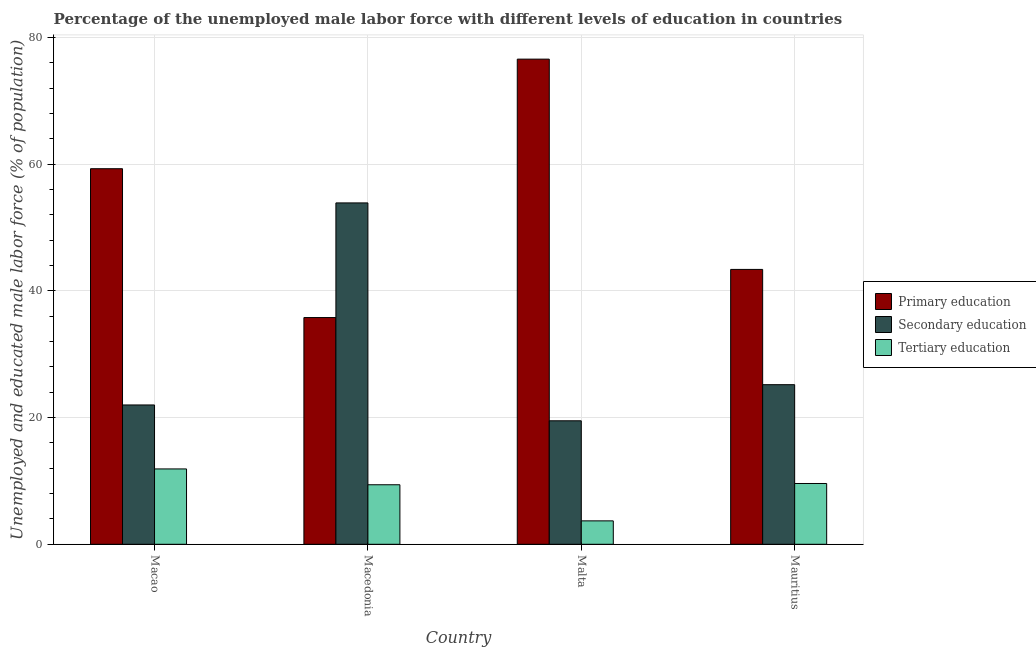How many different coloured bars are there?
Offer a very short reply. 3. How many bars are there on the 3rd tick from the right?
Make the answer very short. 3. What is the label of the 3rd group of bars from the left?
Give a very brief answer. Malta. In how many cases, is the number of bars for a given country not equal to the number of legend labels?
Make the answer very short. 0. What is the percentage of male labor force who received tertiary education in Malta?
Your response must be concise. 3.7. Across all countries, what is the maximum percentage of male labor force who received tertiary education?
Offer a terse response. 11.9. In which country was the percentage of male labor force who received secondary education maximum?
Your response must be concise. Macedonia. In which country was the percentage of male labor force who received secondary education minimum?
Keep it short and to the point. Malta. What is the total percentage of male labor force who received tertiary education in the graph?
Give a very brief answer. 34.6. What is the difference between the percentage of male labor force who received tertiary education in Macao and that in Mauritius?
Provide a succinct answer. 2.3. What is the difference between the percentage of male labor force who received primary education in Macedonia and the percentage of male labor force who received tertiary education in Malta?
Ensure brevity in your answer.  32.1. What is the average percentage of male labor force who received secondary education per country?
Offer a very short reply. 30.15. What is the difference between the percentage of male labor force who received primary education and percentage of male labor force who received tertiary education in Macao?
Make the answer very short. 47.4. What is the ratio of the percentage of male labor force who received secondary education in Macedonia to that in Malta?
Ensure brevity in your answer.  2.76. Is the percentage of male labor force who received primary education in Macao less than that in Macedonia?
Keep it short and to the point. No. What is the difference between the highest and the second highest percentage of male labor force who received tertiary education?
Ensure brevity in your answer.  2.3. What is the difference between the highest and the lowest percentage of male labor force who received secondary education?
Provide a short and direct response. 34.4. Is the sum of the percentage of male labor force who received tertiary education in Macedonia and Mauritius greater than the maximum percentage of male labor force who received secondary education across all countries?
Ensure brevity in your answer.  No. What does the 2nd bar from the left in Macedonia represents?
Your answer should be very brief. Secondary education. What does the 2nd bar from the right in Mauritius represents?
Your answer should be very brief. Secondary education. Are the values on the major ticks of Y-axis written in scientific E-notation?
Give a very brief answer. No. Does the graph contain grids?
Ensure brevity in your answer.  Yes. Where does the legend appear in the graph?
Keep it short and to the point. Center right. How many legend labels are there?
Your response must be concise. 3. What is the title of the graph?
Keep it short and to the point. Percentage of the unemployed male labor force with different levels of education in countries. What is the label or title of the X-axis?
Make the answer very short. Country. What is the label or title of the Y-axis?
Give a very brief answer. Unemployed and educated male labor force (% of population). What is the Unemployed and educated male labor force (% of population) of Primary education in Macao?
Give a very brief answer. 59.3. What is the Unemployed and educated male labor force (% of population) in Secondary education in Macao?
Offer a terse response. 22. What is the Unemployed and educated male labor force (% of population) of Tertiary education in Macao?
Your answer should be very brief. 11.9. What is the Unemployed and educated male labor force (% of population) in Primary education in Macedonia?
Your response must be concise. 35.8. What is the Unemployed and educated male labor force (% of population) of Secondary education in Macedonia?
Offer a terse response. 53.9. What is the Unemployed and educated male labor force (% of population) in Tertiary education in Macedonia?
Your answer should be compact. 9.4. What is the Unemployed and educated male labor force (% of population) of Primary education in Malta?
Offer a terse response. 76.6. What is the Unemployed and educated male labor force (% of population) in Secondary education in Malta?
Give a very brief answer. 19.5. What is the Unemployed and educated male labor force (% of population) in Tertiary education in Malta?
Provide a short and direct response. 3.7. What is the Unemployed and educated male labor force (% of population) in Primary education in Mauritius?
Your answer should be very brief. 43.4. What is the Unemployed and educated male labor force (% of population) in Secondary education in Mauritius?
Provide a short and direct response. 25.2. What is the Unemployed and educated male labor force (% of population) of Tertiary education in Mauritius?
Offer a terse response. 9.6. Across all countries, what is the maximum Unemployed and educated male labor force (% of population) in Primary education?
Provide a succinct answer. 76.6. Across all countries, what is the maximum Unemployed and educated male labor force (% of population) in Secondary education?
Your answer should be compact. 53.9. Across all countries, what is the maximum Unemployed and educated male labor force (% of population) in Tertiary education?
Offer a terse response. 11.9. Across all countries, what is the minimum Unemployed and educated male labor force (% of population) of Primary education?
Give a very brief answer. 35.8. Across all countries, what is the minimum Unemployed and educated male labor force (% of population) in Secondary education?
Provide a succinct answer. 19.5. Across all countries, what is the minimum Unemployed and educated male labor force (% of population) in Tertiary education?
Offer a terse response. 3.7. What is the total Unemployed and educated male labor force (% of population) in Primary education in the graph?
Your response must be concise. 215.1. What is the total Unemployed and educated male labor force (% of population) in Secondary education in the graph?
Give a very brief answer. 120.6. What is the total Unemployed and educated male labor force (% of population) in Tertiary education in the graph?
Make the answer very short. 34.6. What is the difference between the Unemployed and educated male labor force (% of population) of Primary education in Macao and that in Macedonia?
Your answer should be compact. 23.5. What is the difference between the Unemployed and educated male labor force (% of population) in Secondary education in Macao and that in Macedonia?
Offer a very short reply. -31.9. What is the difference between the Unemployed and educated male labor force (% of population) in Tertiary education in Macao and that in Macedonia?
Offer a very short reply. 2.5. What is the difference between the Unemployed and educated male labor force (% of population) of Primary education in Macao and that in Malta?
Offer a terse response. -17.3. What is the difference between the Unemployed and educated male labor force (% of population) of Secondary education in Macao and that in Mauritius?
Your response must be concise. -3.2. What is the difference between the Unemployed and educated male labor force (% of population) in Primary education in Macedonia and that in Malta?
Give a very brief answer. -40.8. What is the difference between the Unemployed and educated male labor force (% of population) of Secondary education in Macedonia and that in Malta?
Provide a short and direct response. 34.4. What is the difference between the Unemployed and educated male labor force (% of population) of Primary education in Macedonia and that in Mauritius?
Provide a short and direct response. -7.6. What is the difference between the Unemployed and educated male labor force (% of population) of Secondary education in Macedonia and that in Mauritius?
Ensure brevity in your answer.  28.7. What is the difference between the Unemployed and educated male labor force (% of population) of Tertiary education in Macedonia and that in Mauritius?
Give a very brief answer. -0.2. What is the difference between the Unemployed and educated male labor force (% of population) of Primary education in Malta and that in Mauritius?
Your answer should be very brief. 33.2. What is the difference between the Unemployed and educated male labor force (% of population) of Tertiary education in Malta and that in Mauritius?
Provide a short and direct response. -5.9. What is the difference between the Unemployed and educated male labor force (% of population) in Primary education in Macao and the Unemployed and educated male labor force (% of population) in Tertiary education in Macedonia?
Keep it short and to the point. 49.9. What is the difference between the Unemployed and educated male labor force (% of population) of Secondary education in Macao and the Unemployed and educated male labor force (% of population) of Tertiary education in Macedonia?
Keep it short and to the point. 12.6. What is the difference between the Unemployed and educated male labor force (% of population) in Primary education in Macao and the Unemployed and educated male labor force (% of population) in Secondary education in Malta?
Make the answer very short. 39.8. What is the difference between the Unemployed and educated male labor force (% of population) in Primary education in Macao and the Unemployed and educated male labor force (% of population) in Tertiary education in Malta?
Ensure brevity in your answer.  55.6. What is the difference between the Unemployed and educated male labor force (% of population) in Primary education in Macao and the Unemployed and educated male labor force (% of population) in Secondary education in Mauritius?
Provide a succinct answer. 34.1. What is the difference between the Unemployed and educated male labor force (% of population) of Primary education in Macao and the Unemployed and educated male labor force (% of population) of Tertiary education in Mauritius?
Offer a terse response. 49.7. What is the difference between the Unemployed and educated male labor force (% of population) of Primary education in Macedonia and the Unemployed and educated male labor force (% of population) of Tertiary education in Malta?
Offer a terse response. 32.1. What is the difference between the Unemployed and educated male labor force (% of population) of Secondary education in Macedonia and the Unemployed and educated male labor force (% of population) of Tertiary education in Malta?
Provide a short and direct response. 50.2. What is the difference between the Unemployed and educated male labor force (% of population) of Primary education in Macedonia and the Unemployed and educated male labor force (% of population) of Tertiary education in Mauritius?
Provide a short and direct response. 26.2. What is the difference between the Unemployed and educated male labor force (% of population) of Secondary education in Macedonia and the Unemployed and educated male labor force (% of population) of Tertiary education in Mauritius?
Provide a succinct answer. 44.3. What is the difference between the Unemployed and educated male labor force (% of population) in Primary education in Malta and the Unemployed and educated male labor force (% of population) in Secondary education in Mauritius?
Provide a succinct answer. 51.4. What is the difference between the Unemployed and educated male labor force (% of population) in Primary education in Malta and the Unemployed and educated male labor force (% of population) in Tertiary education in Mauritius?
Provide a short and direct response. 67. What is the difference between the Unemployed and educated male labor force (% of population) of Secondary education in Malta and the Unemployed and educated male labor force (% of population) of Tertiary education in Mauritius?
Your answer should be very brief. 9.9. What is the average Unemployed and educated male labor force (% of population) of Primary education per country?
Give a very brief answer. 53.77. What is the average Unemployed and educated male labor force (% of population) of Secondary education per country?
Make the answer very short. 30.15. What is the average Unemployed and educated male labor force (% of population) of Tertiary education per country?
Your response must be concise. 8.65. What is the difference between the Unemployed and educated male labor force (% of population) in Primary education and Unemployed and educated male labor force (% of population) in Secondary education in Macao?
Make the answer very short. 37.3. What is the difference between the Unemployed and educated male labor force (% of population) of Primary education and Unemployed and educated male labor force (% of population) of Tertiary education in Macao?
Provide a succinct answer. 47.4. What is the difference between the Unemployed and educated male labor force (% of population) in Primary education and Unemployed and educated male labor force (% of population) in Secondary education in Macedonia?
Your answer should be compact. -18.1. What is the difference between the Unemployed and educated male labor force (% of population) in Primary education and Unemployed and educated male labor force (% of population) in Tertiary education in Macedonia?
Your response must be concise. 26.4. What is the difference between the Unemployed and educated male labor force (% of population) in Secondary education and Unemployed and educated male labor force (% of population) in Tertiary education in Macedonia?
Offer a terse response. 44.5. What is the difference between the Unemployed and educated male labor force (% of population) of Primary education and Unemployed and educated male labor force (% of population) of Secondary education in Malta?
Keep it short and to the point. 57.1. What is the difference between the Unemployed and educated male labor force (% of population) of Primary education and Unemployed and educated male labor force (% of population) of Tertiary education in Malta?
Give a very brief answer. 72.9. What is the difference between the Unemployed and educated male labor force (% of population) in Secondary education and Unemployed and educated male labor force (% of population) in Tertiary education in Malta?
Provide a short and direct response. 15.8. What is the difference between the Unemployed and educated male labor force (% of population) in Primary education and Unemployed and educated male labor force (% of population) in Secondary education in Mauritius?
Offer a terse response. 18.2. What is the difference between the Unemployed and educated male labor force (% of population) in Primary education and Unemployed and educated male labor force (% of population) in Tertiary education in Mauritius?
Offer a terse response. 33.8. What is the difference between the Unemployed and educated male labor force (% of population) in Secondary education and Unemployed and educated male labor force (% of population) in Tertiary education in Mauritius?
Ensure brevity in your answer.  15.6. What is the ratio of the Unemployed and educated male labor force (% of population) of Primary education in Macao to that in Macedonia?
Keep it short and to the point. 1.66. What is the ratio of the Unemployed and educated male labor force (% of population) of Secondary education in Macao to that in Macedonia?
Provide a succinct answer. 0.41. What is the ratio of the Unemployed and educated male labor force (% of population) in Tertiary education in Macao to that in Macedonia?
Provide a short and direct response. 1.27. What is the ratio of the Unemployed and educated male labor force (% of population) in Primary education in Macao to that in Malta?
Your answer should be compact. 0.77. What is the ratio of the Unemployed and educated male labor force (% of population) in Secondary education in Macao to that in Malta?
Provide a short and direct response. 1.13. What is the ratio of the Unemployed and educated male labor force (% of population) in Tertiary education in Macao to that in Malta?
Provide a succinct answer. 3.22. What is the ratio of the Unemployed and educated male labor force (% of population) of Primary education in Macao to that in Mauritius?
Make the answer very short. 1.37. What is the ratio of the Unemployed and educated male labor force (% of population) of Secondary education in Macao to that in Mauritius?
Give a very brief answer. 0.87. What is the ratio of the Unemployed and educated male labor force (% of population) of Tertiary education in Macao to that in Mauritius?
Offer a terse response. 1.24. What is the ratio of the Unemployed and educated male labor force (% of population) in Primary education in Macedonia to that in Malta?
Your answer should be compact. 0.47. What is the ratio of the Unemployed and educated male labor force (% of population) in Secondary education in Macedonia to that in Malta?
Give a very brief answer. 2.76. What is the ratio of the Unemployed and educated male labor force (% of population) of Tertiary education in Macedonia to that in Malta?
Provide a short and direct response. 2.54. What is the ratio of the Unemployed and educated male labor force (% of population) in Primary education in Macedonia to that in Mauritius?
Provide a succinct answer. 0.82. What is the ratio of the Unemployed and educated male labor force (% of population) of Secondary education in Macedonia to that in Mauritius?
Make the answer very short. 2.14. What is the ratio of the Unemployed and educated male labor force (% of population) of Tertiary education in Macedonia to that in Mauritius?
Offer a very short reply. 0.98. What is the ratio of the Unemployed and educated male labor force (% of population) of Primary education in Malta to that in Mauritius?
Provide a short and direct response. 1.76. What is the ratio of the Unemployed and educated male labor force (% of population) in Secondary education in Malta to that in Mauritius?
Give a very brief answer. 0.77. What is the ratio of the Unemployed and educated male labor force (% of population) in Tertiary education in Malta to that in Mauritius?
Offer a terse response. 0.39. What is the difference between the highest and the second highest Unemployed and educated male labor force (% of population) in Secondary education?
Offer a very short reply. 28.7. What is the difference between the highest and the second highest Unemployed and educated male labor force (% of population) of Tertiary education?
Give a very brief answer. 2.3. What is the difference between the highest and the lowest Unemployed and educated male labor force (% of population) of Primary education?
Keep it short and to the point. 40.8. What is the difference between the highest and the lowest Unemployed and educated male labor force (% of population) in Secondary education?
Your answer should be very brief. 34.4. What is the difference between the highest and the lowest Unemployed and educated male labor force (% of population) of Tertiary education?
Keep it short and to the point. 8.2. 